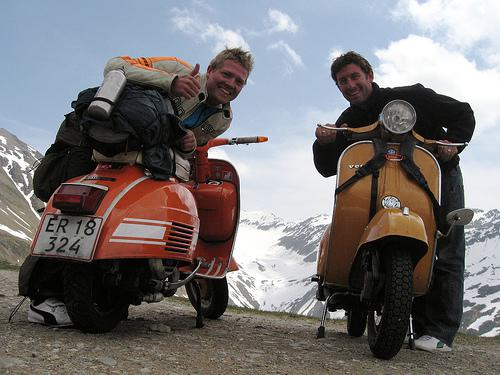Do the motorbikes have any distinguishing features? Yes, the motorbikes each have their unique colors and styles. The one on the left has a vibrant orange color reminiscent of classic European designs, and it's loaded with travel gear. The one on the right has a more subdued cream or pale yellow color, and it has a sleek, vintage look typical of scooters from the mid-20th century. 